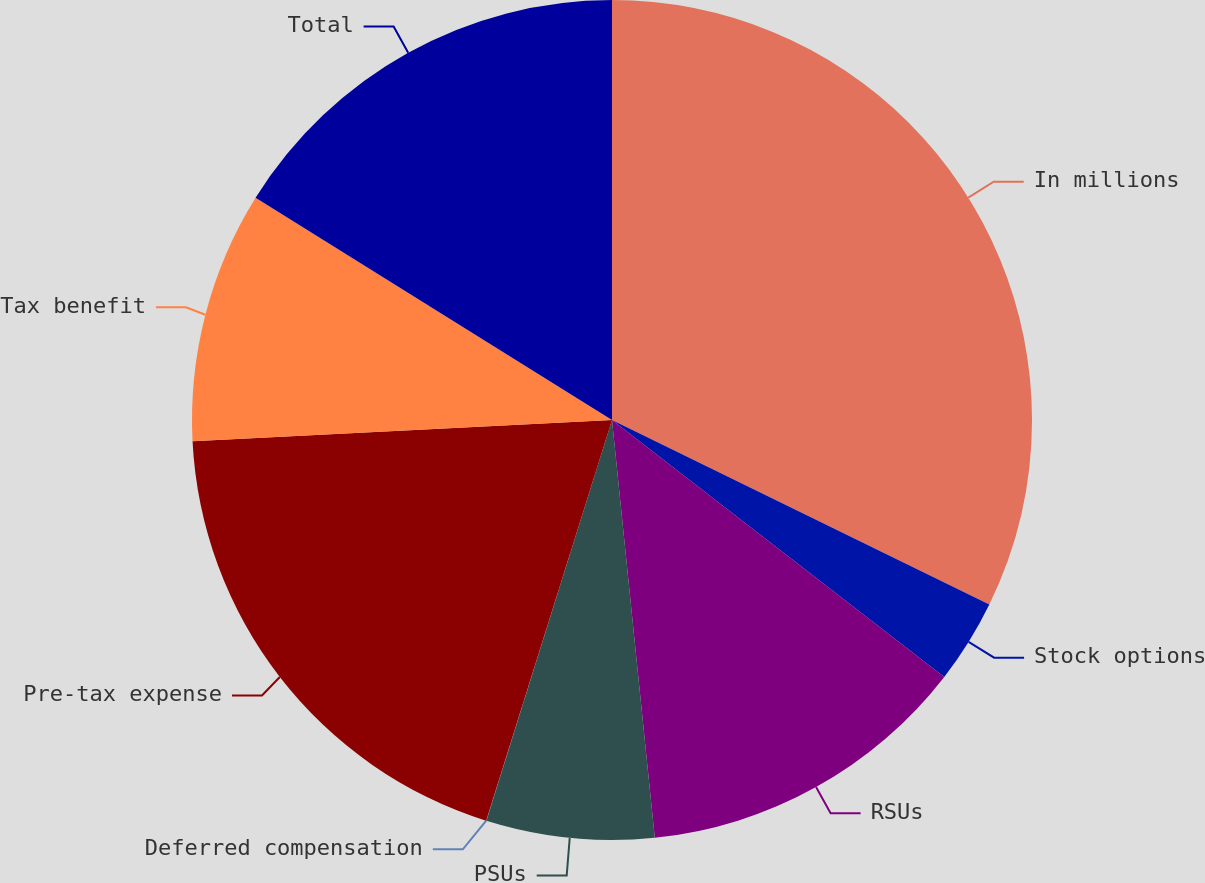Convert chart to OTSL. <chart><loc_0><loc_0><loc_500><loc_500><pie_chart><fcel>In millions<fcel>Stock options<fcel>RSUs<fcel>PSUs<fcel>Deferred compensation<fcel>Pre-tax expense<fcel>Tax benefit<fcel>Total<nl><fcel>32.24%<fcel>3.24%<fcel>12.9%<fcel>6.46%<fcel>0.01%<fcel>19.35%<fcel>9.68%<fcel>16.13%<nl></chart> 